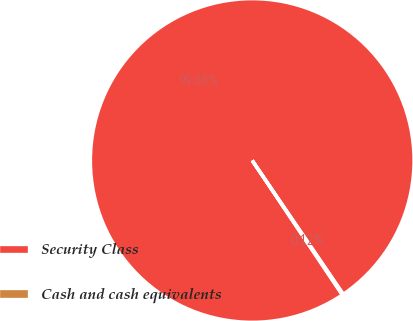Convert chart. <chart><loc_0><loc_0><loc_500><loc_500><pie_chart><fcel>Security Class<fcel>Cash and cash equivalents<nl><fcel>99.88%<fcel>0.12%<nl></chart> 